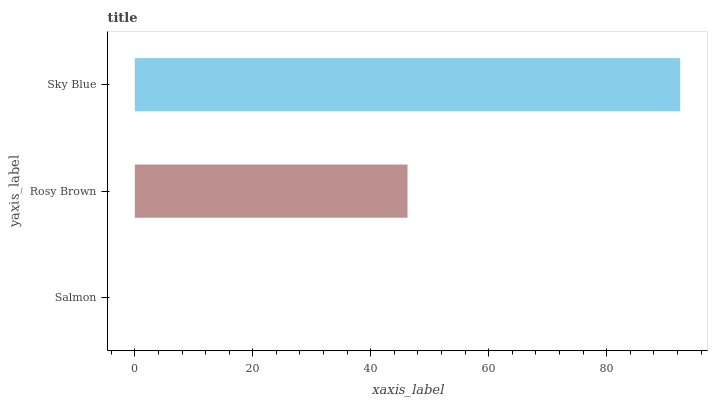Is Salmon the minimum?
Answer yes or no. Yes. Is Sky Blue the maximum?
Answer yes or no. Yes. Is Rosy Brown the minimum?
Answer yes or no. No. Is Rosy Brown the maximum?
Answer yes or no. No. Is Rosy Brown greater than Salmon?
Answer yes or no. Yes. Is Salmon less than Rosy Brown?
Answer yes or no. Yes. Is Salmon greater than Rosy Brown?
Answer yes or no. No. Is Rosy Brown less than Salmon?
Answer yes or no. No. Is Rosy Brown the high median?
Answer yes or no. Yes. Is Rosy Brown the low median?
Answer yes or no. Yes. Is Salmon the high median?
Answer yes or no. No. Is Sky Blue the low median?
Answer yes or no. No. 